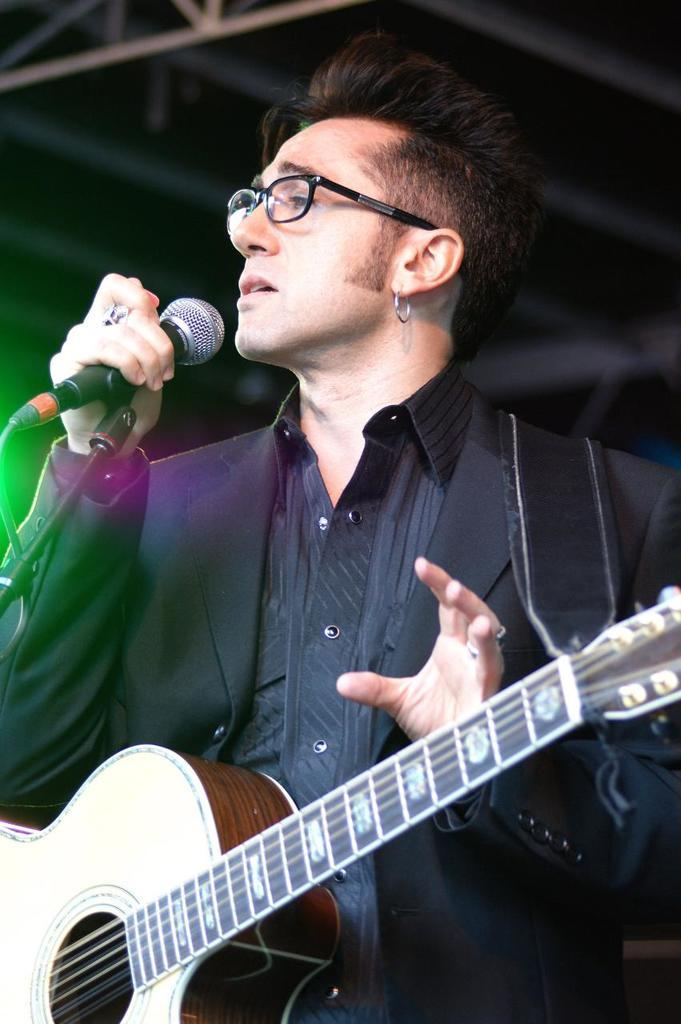What is the person in the image doing? The person is holding a microphone in the image. What object is the person holding in front of them? The microphone is in front of the person. What other item is the person carrying? The person is carrying a guitar. What type of sofa can be seen in the image? There is no sofa present in the image. Can you tell me the person's tendency to whistle while holding the microphone? There is no information about the person's tendency to whistle in the image. 